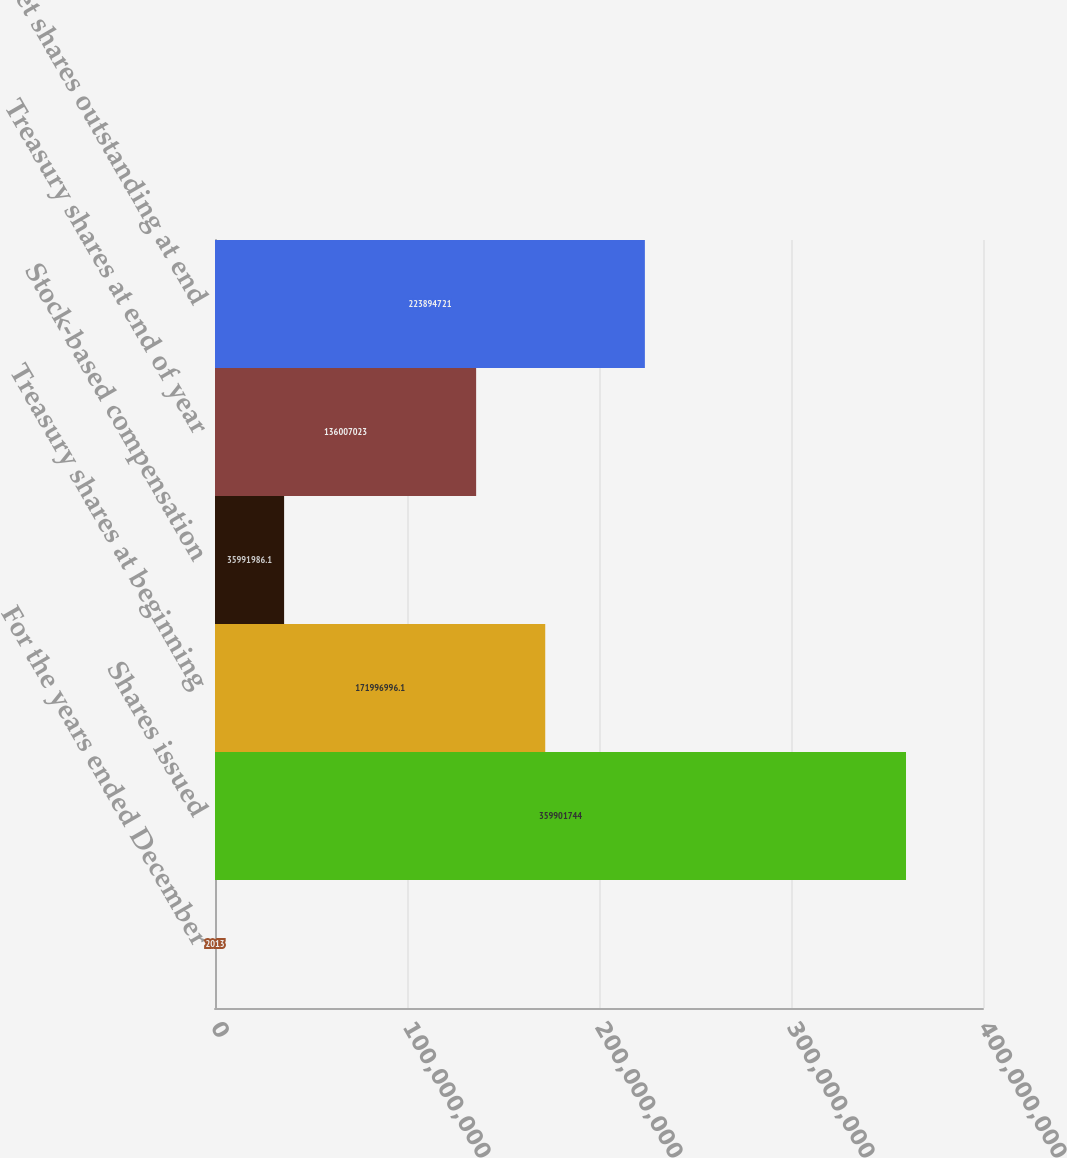<chart> <loc_0><loc_0><loc_500><loc_500><bar_chart><fcel>For the years ended December<fcel>Shares issued<fcel>Treasury shares at beginning<fcel>Stock-based compensation<fcel>Treasury shares at end of year<fcel>Net shares outstanding at end<nl><fcel>2013<fcel>3.59902e+08<fcel>1.71997e+08<fcel>3.5992e+07<fcel>1.36007e+08<fcel>2.23895e+08<nl></chart> 